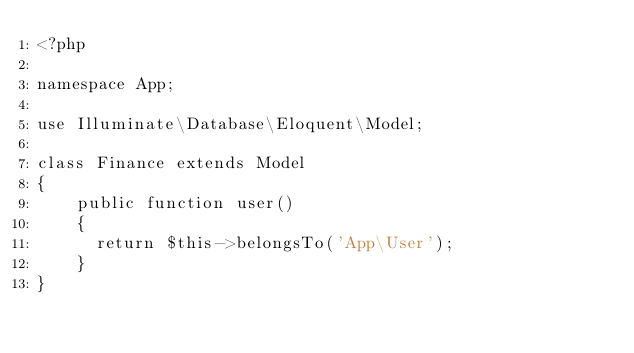Convert code to text. <code><loc_0><loc_0><loc_500><loc_500><_PHP_><?php

namespace App;

use Illuminate\Database\Eloquent\Model;

class Finance extends Model
{
    public function user()
    {
      return $this->belongsTo('App\User');
    }
}
</code> 